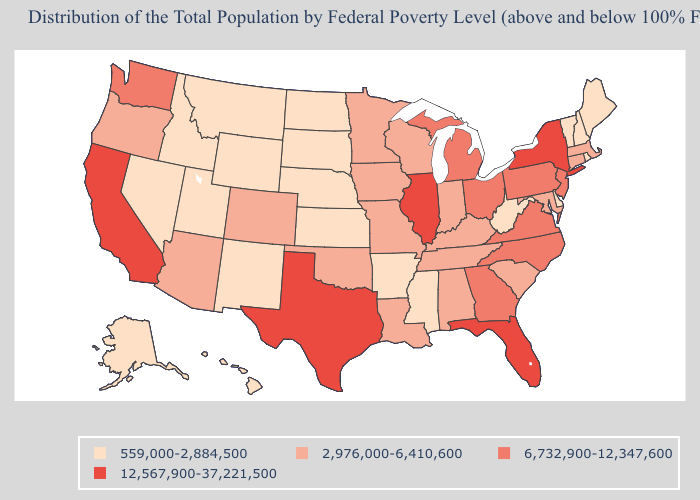Name the states that have a value in the range 6,732,900-12,347,600?
Give a very brief answer. Georgia, Michigan, New Jersey, North Carolina, Ohio, Pennsylvania, Virginia, Washington. Which states have the lowest value in the MidWest?
Be succinct. Kansas, Nebraska, North Dakota, South Dakota. Which states have the highest value in the USA?
Answer briefly. California, Florida, Illinois, New York, Texas. What is the highest value in states that border Pennsylvania?
Concise answer only. 12,567,900-37,221,500. What is the value of Kansas?
Be succinct. 559,000-2,884,500. What is the value of Utah?
Short answer required. 559,000-2,884,500. What is the value of Montana?
Quick response, please. 559,000-2,884,500. Name the states that have a value in the range 6,732,900-12,347,600?
Be succinct. Georgia, Michigan, New Jersey, North Carolina, Ohio, Pennsylvania, Virginia, Washington. What is the value of Wisconsin?
Answer briefly. 2,976,000-6,410,600. Does Massachusetts have the highest value in the Northeast?
Short answer required. No. What is the value of Kansas?
Short answer required. 559,000-2,884,500. Name the states that have a value in the range 6,732,900-12,347,600?
Short answer required. Georgia, Michigan, New Jersey, North Carolina, Ohio, Pennsylvania, Virginia, Washington. Which states hav the highest value in the Northeast?
Be succinct. New York. What is the value of Iowa?
Write a very short answer. 2,976,000-6,410,600. 